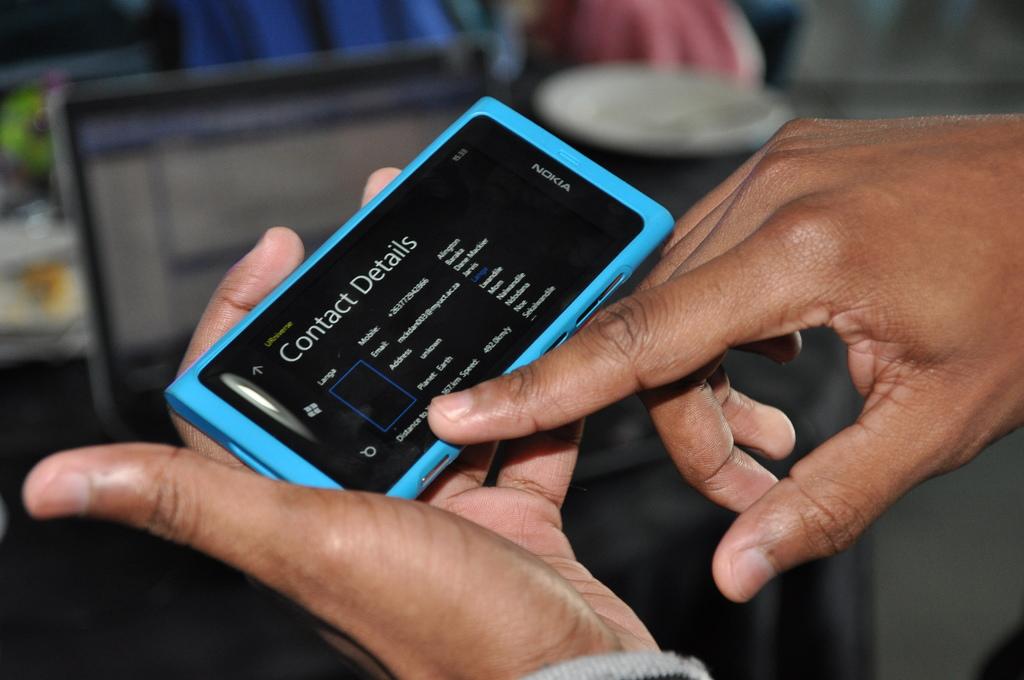Which company made this phone?
Give a very brief answer. Nokia. What details are on the screen?
Make the answer very short. Contact details. 